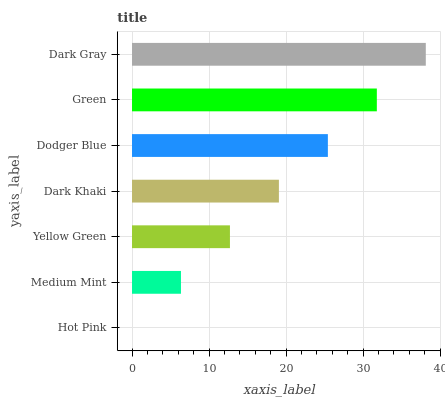Is Hot Pink the minimum?
Answer yes or no. Yes. Is Dark Gray the maximum?
Answer yes or no. Yes. Is Medium Mint the minimum?
Answer yes or no. No. Is Medium Mint the maximum?
Answer yes or no. No. Is Medium Mint greater than Hot Pink?
Answer yes or no. Yes. Is Hot Pink less than Medium Mint?
Answer yes or no. Yes. Is Hot Pink greater than Medium Mint?
Answer yes or no. No. Is Medium Mint less than Hot Pink?
Answer yes or no. No. Is Dark Khaki the high median?
Answer yes or no. Yes. Is Dark Khaki the low median?
Answer yes or no. Yes. Is Green the high median?
Answer yes or no. No. Is Yellow Green the low median?
Answer yes or no. No. 